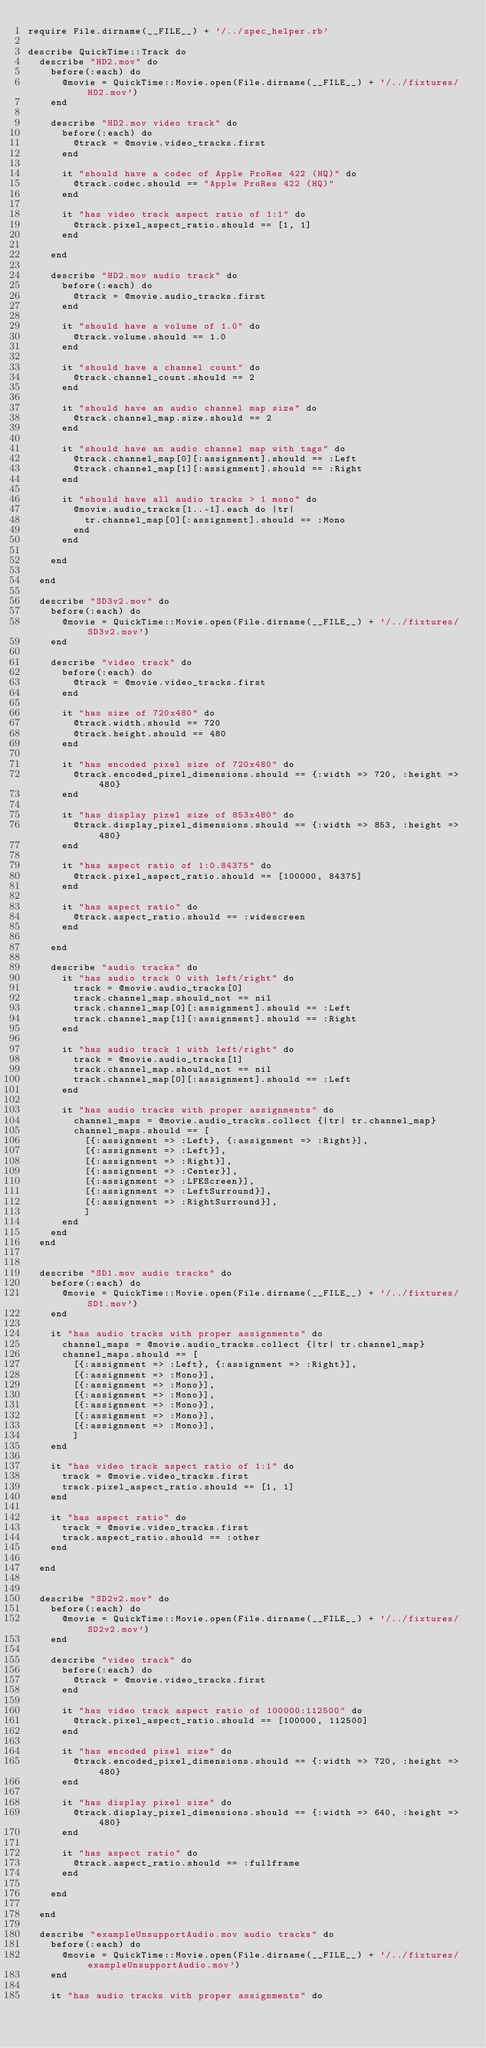<code> <loc_0><loc_0><loc_500><loc_500><_Ruby_>require File.dirname(__FILE__) + '/../spec_helper.rb'

describe QuickTime::Track do
  describe "HD2.mov" do
    before(:each) do
      @movie = QuickTime::Movie.open(File.dirname(__FILE__) + '/../fixtures/HD2.mov')
    end
 
    describe "HD2.mov video track" do
      before(:each) do
        @track = @movie.video_tracks.first
      end

      it "should have a codec of Apple ProRes 422 (HQ)" do
        @track.codec.should == "Apple ProRes 422 (HQ)"
      end

      it "has video track aspect ratio of 1:1" do
        @track.pixel_aspect_ratio.should == [1, 1]
      end

    end
  
    describe "HD2.mov audio track" do 
      before(:each) do
        @track = @movie.audio_tracks.first
      end
    
      it "should have a volume of 1.0" do
        @track.volume.should == 1.0
      end
      
      it "should have a channel count" do 
        @track.channel_count.should == 2
      end
      
      it "should have an audio channel map size" do
        @track.channel_map.size.should == 2
      end
      
      it "should have an audio channel map with tags" do
        @track.channel_map[0][:assignment].should == :Left
        @track.channel_map[1][:assignment].should == :Right
      end
      
      it "should have all audio tracks > 1 mono" do
        @movie.audio_tracks[1..-1].each do |tr|
          tr.channel_map[0][:assignment].should == :Mono
        end
      end

    end

  end  

  describe "SD3v2.mov" do
    before(:each) do
      @movie = QuickTime::Movie.open(File.dirname(__FILE__) + '/../fixtures/SD3v2.mov')
    end
    
    describe "video track" do
      before(:each) do
        @track = @movie.video_tracks.first
      end

      it "has size of 720x480" do
        @track.width.should == 720
        @track.height.should == 480
      end
    
      it "has encoded pixel size of 720x480" do
        @track.encoded_pixel_dimensions.should == {:width => 720, :height => 480}
      end
    
      it "has display pixel size of 853x480" do
        @track.display_pixel_dimensions.should == {:width => 853, :height => 480}
      end

      it "has aspect ratio of 1:0.84375" do
        @track.pixel_aspect_ratio.should == [100000, 84375]
      end
      
      it "has aspect ratio" do
        @track.aspect_ratio.should == :widescreen
      end
      
    end

    describe "audio tracks" do
      it "has audio track 0 with left/right" do
        track = @movie.audio_tracks[0]
        track.channel_map.should_not == nil
        track.channel_map[0][:assignment].should == :Left
        track.channel_map[1][:assignment].should == :Right
      end

      it "has audio track 1 with left/right" do
        track = @movie.audio_tracks[1]
        track.channel_map.should_not == nil
        track.channel_map[0][:assignment].should == :Left
      end
    
      it "has audio tracks with proper assignments" do
        channel_maps = @movie.audio_tracks.collect {|tr| tr.channel_map}
        channel_maps.should == [
          [{:assignment => :Left}, {:assignment => :Right}],
          [{:assignment => :Left}],
          [{:assignment => :Right}],
          [{:assignment => :Center}],
          [{:assignment => :LFEScreen}],
          [{:assignment => :LeftSurround}],
          [{:assignment => :RightSurround}],
          ]
      end
    end
  end
  
  
  describe "SD1.mov audio tracks" do
    before(:each) do
      @movie = QuickTime::Movie.open(File.dirname(__FILE__) + '/../fixtures/SD1.mov')
    end
    
    it "has audio tracks with proper assignments" do
      channel_maps = @movie.audio_tracks.collect {|tr| tr.channel_map}
      channel_maps.should == [
        [{:assignment => :Left}, {:assignment => :Right}],
        [{:assignment => :Mono}],
        [{:assignment => :Mono}],
        [{:assignment => :Mono}],
        [{:assignment => :Mono}],
        [{:assignment => :Mono}],
        [{:assignment => :Mono}],
        ]
    end
    
    it "has video track aspect ratio of 1:1" do
      track = @movie.video_tracks.first
      track.pixel_aspect_ratio.should == [1, 1]
    end
    
    it "has aspect ratio" do
      track = @movie.video_tracks.first
      track.aspect_ratio.should == :other
    end
    
  end


  describe "SD2v2.mov" do
    before(:each) do
      @movie = QuickTime::Movie.open(File.dirname(__FILE__) + '/../fixtures/SD2v2.mov')
    end
    
    describe "video track" do
      before(:each) do
        @track = @movie.video_tracks.first
      end

      it "has video track aspect ratio of 100000:112500" do
        @track.pixel_aspect_ratio.should == [100000, 112500]
      end

      it "has encoded pixel size" do
        @track.encoded_pixel_dimensions.should == {:width => 720, :height => 480}
      end

      it "has display pixel size" do
        @track.display_pixel_dimensions.should == {:width => 640, :height => 480}
      end
      
      it "has aspect ratio" do
        @track.aspect_ratio.should == :fullframe
      end

    end

  end

  describe "exampleUnsupportAudio.mov audio tracks" do
    before(:each) do
      @movie = QuickTime::Movie.open(File.dirname(__FILE__) + '/../fixtures/exampleUnsupportAudio.mov')
    end
    
    it "has audio tracks with proper assignments" do</code> 